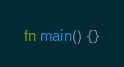<code> <loc_0><loc_0><loc_500><loc_500><_Rust_>fn main() {}
</code> 